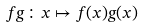Convert formula to latex. <formula><loc_0><loc_0><loc_500><loc_500>f g \colon x \mapsto f ( x ) g ( x )</formula> 